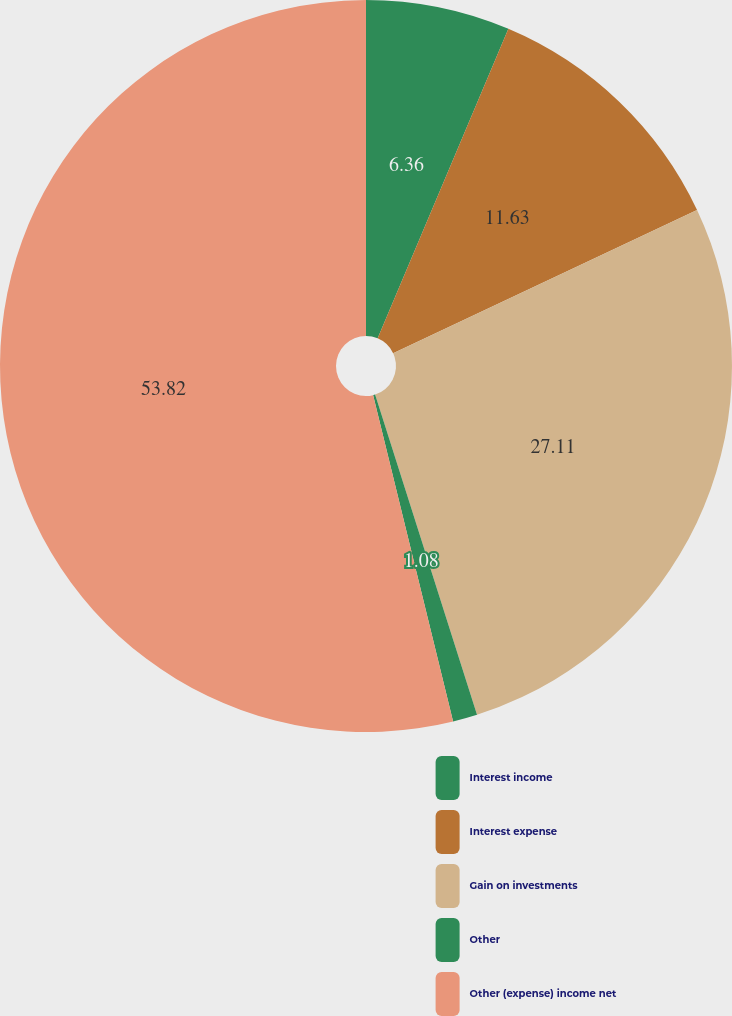Convert chart. <chart><loc_0><loc_0><loc_500><loc_500><pie_chart><fcel>Interest income<fcel>Interest expense<fcel>Gain on investments<fcel>Other<fcel>Other (expense) income net<nl><fcel>6.36%<fcel>11.63%<fcel>27.11%<fcel>1.08%<fcel>53.83%<nl></chart> 